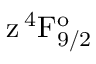<formula> <loc_0><loc_0><loc_500><loc_500>z \, ^ { 4 } F _ { 9 / 2 } ^ { o }</formula> 